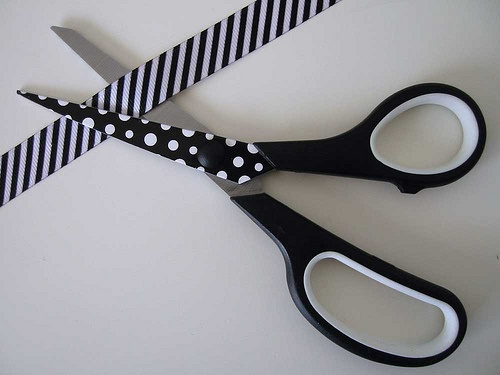Describe the objects in this image and their specific colors. I can see scissors in darkgray, black, and gray tones in this image. 